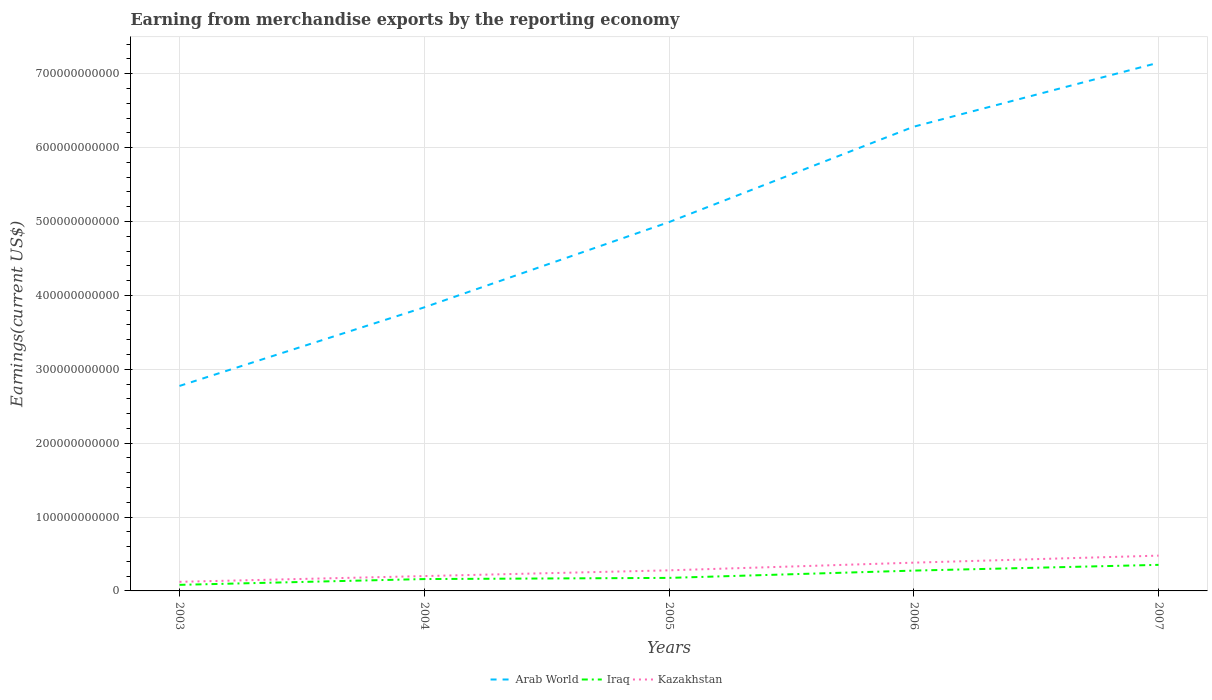How many different coloured lines are there?
Make the answer very short. 3. Across all years, what is the maximum amount earned from merchandise exports in Iraq?
Your answer should be compact. 8.22e+09. What is the total amount earned from merchandise exports in Iraq in the graph?
Offer a terse response. -1.14e+1. What is the difference between the highest and the second highest amount earned from merchandise exports in Iraq?
Offer a terse response. 2.71e+1. What is the difference between the highest and the lowest amount earned from merchandise exports in Iraq?
Provide a succinct answer. 2. Is the amount earned from merchandise exports in Iraq strictly greater than the amount earned from merchandise exports in Kazakhstan over the years?
Give a very brief answer. Yes. What is the difference between two consecutive major ticks on the Y-axis?
Ensure brevity in your answer.  1.00e+11. Are the values on the major ticks of Y-axis written in scientific E-notation?
Your answer should be compact. No. Does the graph contain any zero values?
Your answer should be compact. No. Does the graph contain grids?
Your answer should be very brief. Yes. Where does the legend appear in the graph?
Your answer should be very brief. Bottom center. What is the title of the graph?
Ensure brevity in your answer.  Earning from merchandise exports by the reporting economy. Does "Sub-Saharan Africa (developing only)" appear as one of the legend labels in the graph?
Keep it short and to the point. No. What is the label or title of the X-axis?
Provide a succinct answer. Years. What is the label or title of the Y-axis?
Your response must be concise. Earnings(current US$). What is the Earnings(current US$) in Arab World in 2003?
Your answer should be compact. 2.77e+11. What is the Earnings(current US$) of Iraq in 2003?
Your answer should be very brief. 8.22e+09. What is the Earnings(current US$) of Kazakhstan in 2003?
Keep it short and to the point. 1.23e+1. What is the Earnings(current US$) of Arab World in 2004?
Keep it short and to the point. 3.84e+11. What is the Earnings(current US$) of Iraq in 2004?
Your answer should be compact. 1.61e+1. What is the Earnings(current US$) of Kazakhstan in 2004?
Provide a short and direct response. 2.01e+1. What is the Earnings(current US$) of Arab World in 2005?
Your response must be concise. 4.99e+11. What is the Earnings(current US$) of Iraq in 2005?
Your response must be concise. 1.76e+1. What is the Earnings(current US$) in Kazakhstan in 2005?
Your answer should be compact. 2.79e+1. What is the Earnings(current US$) in Arab World in 2006?
Keep it short and to the point. 6.28e+11. What is the Earnings(current US$) in Iraq in 2006?
Provide a short and direct response. 2.75e+1. What is the Earnings(current US$) of Kazakhstan in 2006?
Your answer should be very brief. 3.83e+1. What is the Earnings(current US$) of Arab World in 2007?
Keep it short and to the point. 7.15e+11. What is the Earnings(current US$) in Iraq in 2007?
Your response must be concise. 3.53e+1. What is the Earnings(current US$) of Kazakhstan in 2007?
Keep it short and to the point. 4.78e+1. Across all years, what is the maximum Earnings(current US$) in Arab World?
Keep it short and to the point. 7.15e+11. Across all years, what is the maximum Earnings(current US$) of Iraq?
Your answer should be very brief. 3.53e+1. Across all years, what is the maximum Earnings(current US$) of Kazakhstan?
Offer a very short reply. 4.78e+1. Across all years, what is the minimum Earnings(current US$) of Arab World?
Your response must be concise. 2.77e+11. Across all years, what is the minimum Earnings(current US$) in Iraq?
Your answer should be compact. 8.22e+09. Across all years, what is the minimum Earnings(current US$) of Kazakhstan?
Offer a terse response. 1.23e+1. What is the total Earnings(current US$) of Arab World in the graph?
Make the answer very short. 2.50e+12. What is the total Earnings(current US$) in Iraq in the graph?
Keep it short and to the point. 1.05e+11. What is the total Earnings(current US$) in Kazakhstan in the graph?
Your answer should be compact. 1.46e+11. What is the difference between the Earnings(current US$) in Arab World in 2003 and that in 2004?
Ensure brevity in your answer.  -1.06e+11. What is the difference between the Earnings(current US$) in Iraq in 2003 and that in 2004?
Offer a very short reply. -7.84e+09. What is the difference between the Earnings(current US$) of Kazakhstan in 2003 and that in 2004?
Offer a very short reply. -7.79e+09. What is the difference between the Earnings(current US$) in Arab World in 2003 and that in 2005?
Keep it short and to the point. -2.22e+11. What is the difference between the Earnings(current US$) of Iraq in 2003 and that in 2005?
Offer a very short reply. -9.41e+09. What is the difference between the Earnings(current US$) in Kazakhstan in 2003 and that in 2005?
Keep it short and to the point. -1.55e+1. What is the difference between the Earnings(current US$) in Arab World in 2003 and that in 2006?
Offer a terse response. -3.51e+11. What is the difference between the Earnings(current US$) in Iraq in 2003 and that in 2006?
Offer a terse response. -1.93e+1. What is the difference between the Earnings(current US$) of Kazakhstan in 2003 and that in 2006?
Your response must be concise. -2.59e+1. What is the difference between the Earnings(current US$) of Arab World in 2003 and that in 2007?
Provide a succinct answer. -4.37e+11. What is the difference between the Earnings(current US$) in Iraq in 2003 and that in 2007?
Provide a short and direct response. -2.71e+1. What is the difference between the Earnings(current US$) in Kazakhstan in 2003 and that in 2007?
Offer a very short reply. -3.55e+1. What is the difference between the Earnings(current US$) of Arab World in 2004 and that in 2005?
Provide a short and direct response. -1.15e+11. What is the difference between the Earnings(current US$) in Iraq in 2004 and that in 2005?
Provide a short and direct response. -1.58e+09. What is the difference between the Earnings(current US$) of Kazakhstan in 2004 and that in 2005?
Make the answer very short. -7.76e+09. What is the difference between the Earnings(current US$) of Arab World in 2004 and that in 2006?
Offer a very short reply. -2.45e+11. What is the difference between the Earnings(current US$) in Iraq in 2004 and that in 2006?
Your answer should be very brief. -1.14e+1. What is the difference between the Earnings(current US$) of Kazakhstan in 2004 and that in 2006?
Your answer should be very brief. -1.82e+1. What is the difference between the Earnings(current US$) of Arab World in 2004 and that in 2007?
Provide a short and direct response. -3.31e+11. What is the difference between the Earnings(current US$) of Iraq in 2004 and that in 2007?
Make the answer very short. -1.92e+1. What is the difference between the Earnings(current US$) of Kazakhstan in 2004 and that in 2007?
Your answer should be very brief. -2.77e+1. What is the difference between the Earnings(current US$) of Arab World in 2005 and that in 2006?
Make the answer very short. -1.29e+11. What is the difference between the Earnings(current US$) of Iraq in 2005 and that in 2006?
Provide a succinct answer. -9.87e+09. What is the difference between the Earnings(current US$) in Kazakhstan in 2005 and that in 2006?
Your answer should be compact. -1.04e+1. What is the difference between the Earnings(current US$) of Arab World in 2005 and that in 2007?
Your response must be concise. -2.16e+11. What is the difference between the Earnings(current US$) of Iraq in 2005 and that in 2007?
Your response must be concise. -1.76e+1. What is the difference between the Earnings(current US$) of Kazakhstan in 2005 and that in 2007?
Offer a very short reply. -1.99e+1. What is the difference between the Earnings(current US$) of Arab World in 2006 and that in 2007?
Provide a succinct answer. -8.66e+1. What is the difference between the Earnings(current US$) of Iraq in 2006 and that in 2007?
Give a very brief answer. -7.77e+09. What is the difference between the Earnings(current US$) of Kazakhstan in 2006 and that in 2007?
Your answer should be compact. -9.51e+09. What is the difference between the Earnings(current US$) of Arab World in 2003 and the Earnings(current US$) of Iraq in 2004?
Your answer should be compact. 2.61e+11. What is the difference between the Earnings(current US$) in Arab World in 2003 and the Earnings(current US$) in Kazakhstan in 2004?
Make the answer very short. 2.57e+11. What is the difference between the Earnings(current US$) in Iraq in 2003 and the Earnings(current US$) in Kazakhstan in 2004?
Offer a terse response. -1.19e+1. What is the difference between the Earnings(current US$) in Arab World in 2003 and the Earnings(current US$) in Iraq in 2005?
Your answer should be very brief. 2.60e+11. What is the difference between the Earnings(current US$) in Arab World in 2003 and the Earnings(current US$) in Kazakhstan in 2005?
Provide a short and direct response. 2.50e+11. What is the difference between the Earnings(current US$) in Iraq in 2003 and the Earnings(current US$) in Kazakhstan in 2005?
Your response must be concise. -1.96e+1. What is the difference between the Earnings(current US$) in Arab World in 2003 and the Earnings(current US$) in Iraq in 2006?
Keep it short and to the point. 2.50e+11. What is the difference between the Earnings(current US$) in Arab World in 2003 and the Earnings(current US$) in Kazakhstan in 2006?
Make the answer very short. 2.39e+11. What is the difference between the Earnings(current US$) of Iraq in 2003 and the Earnings(current US$) of Kazakhstan in 2006?
Your response must be concise. -3.00e+1. What is the difference between the Earnings(current US$) in Arab World in 2003 and the Earnings(current US$) in Iraq in 2007?
Provide a succinct answer. 2.42e+11. What is the difference between the Earnings(current US$) in Arab World in 2003 and the Earnings(current US$) in Kazakhstan in 2007?
Your answer should be very brief. 2.30e+11. What is the difference between the Earnings(current US$) in Iraq in 2003 and the Earnings(current US$) in Kazakhstan in 2007?
Keep it short and to the point. -3.95e+1. What is the difference between the Earnings(current US$) of Arab World in 2004 and the Earnings(current US$) of Iraq in 2005?
Your answer should be compact. 3.66e+11. What is the difference between the Earnings(current US$) in Arab World in 2004 and the Earnings(current US$) in Kazakhstan in 2005?
Offer a very short reply. 3.56e+11. What is the difference between the Earnings(current US$) of Iraq in 2004 and the Earnings(current US$) of Kazakhstan in 2005?
Offer a terse response. -1.18e+1. What is the difference between the Earnings(current US$) in Arab World in 2004 and the Earnings(current US$) in Iraq in 2006?
Keep it short and to the point. 3.56e+11. What is the difference between the Earnings(current US$) of Arab World in 2004 and the Earnings(current US$) of Kazakhstan in 2006?
Make the answer very short. 3.46e+11. What is the difference between the Earnings(current US$) in Iraq in 2004 and the Earnings(current US$) in Kazakhstan in 2006?
Offer a very short reply. -2.22e+1. What is the difference between the Earnings(current US$) of Arab World in 2004 and the Earnings(current US$) of Iraq in 2007?
Ensure brevity in your answer.  3.48e+11. What is the difference between the Earnings(current US$) of Arab World in 2004 and the Earnings(current US$) of Kazakhstan in 2007?
Provide a short and direct response. 3.36e+11. What is the difference between the Earnings(current US$) of Iraq in 2004 and the Earnings(current US$) of Kazakhstan in 2007?
Keep it short and to the point. -3.17e+1. What is the difference between the Earnings(current US$) in Arab World in 2005 and the Earnings(current US$) in Iraq in 2006?
Offer a very short reply. 4.72e+11. What is the difference between the Earnings(current US$) in Arab World in 2005 and the Earnings(current US$) in Kazakhstan in 2006?
Offer a very short reply. 4.61e+11. What is the difference between the Earnings(current US$) of Iraq in 2005 and the Earnings(current US$) of Kazakhstan in 2006?
Keep it short and to the point. -2.06e+1. What is the difference between the Earnings(current US$) in Arab World in 2005 and the Earnings(current US$) in Iraq in 2007?
Provide a succinct answer. 4.64e+11. What is the difference between the Earnings(current US$) of Arab World in 2005 and the Earnings(current US$) of Kazakhstan in 2007?
Your response must be concise. 4.51e+11. What is the difference between the Earnings(current US$) in Iraq in 2005 and the Earnings(current US$) in Kazakhstan in 2007?
Offer a very short reply. -3.01e+1. What is the difference between the Earnings(current US$) in Arab World in 2006 and the Earnings(current US$) in Iraq in 2007?
Offer a very short reply. 5.93e+11. What is the difference between the Earnings(current US$) of Arab World in 2006 and the Earnings(current US$) of Kazakhstan in 2007?
Offer a very short reply. 5.81e+11. What is the difference between the Earnings(current US$) in Iraq in 2006 and the Earnings(current US$) in Kazakhstan in 2007?
Keep it short and to the point. -2.03e+1. What is the average Earnings(current US$) of Arab World per year?
Keep it short and to the point. 5.01e+11. What is the average Earnings(current US$) in Iraq per year?
Provide a succinct answer. 2.09e+1. What is the average Earnings(current US$) of Kazakhstan per year?
Your answer should be very brief. 2.93e+1. In the year 2003, what is the difference between the Earnings(current US$) in Arab World and Earnings(current US$) in Iraq?
Ensure brevity in your answer.  2.69e+11. In the year 2003, what is the difference between the Earnings(current US$) in Arab World and Earnings(current US$) in Kazakhstan?
Offer a terse response. 2.65e+11. In the year 2003, what is the difference between the Earnings(current US$) in Iraq and Earnings(current US$) in Kazakhstan?
Your answer should be very brief. -4.09e+09. In the year 2004, what is the difference between the Earnings(current US$) in Arab World and Earnings(current US$) in Iraq?
Offer a very short reply. 3.68e+11. In the year 2004, what is the difference between the Earnings(current US$) of Arab World and Earnings(current US$) of Kazakhstan?
Your response must be concise. 3.64e+11. In the year 2004, what is the difference between the Earnings(current US$) of Iraq and Earnings(current US$) of Kazakhstan?
Offer a very short reply. -4.04e+09. In the year 2005, what is the difference between the Earnings(current US$) of Arab World and Earnings(current US$) of Iraq?
Your answer should be very brief. 4.82e+11. In the year 2005, what is the difference between the Earnings(current US$) in Arab World and Earnings(current US$) in Kazakhstan?
Offer a very short reply. 4.71e+11. In the year 2005, what is the difference between the Earnings(current US$) in Iraq and Earnings(current US$) in Kazakhstan?
Ensure brevity in your answer.  -1.02e+1. In the year 2006, what is the difference between the Earnings(current US$) in Arab World and Earnings(current US$) in Iraq?
Offer a very short reply. 6.01e+11. In the year 2006, what is the difference between the Earnings(current US$) of Arab World and Earnings(current US$) of Kazakhstan?
Provide a succinct answer. 5.90e+11. In the year 2006, what is the difference between the Earnings(current US$) of Iraq and Earnings(current US$) of Kazakhstan?
Make the answer very short. -1.08e+1. In the year 2007, what is the difference between the Earnings(current US$) in Arab World and Earnings(current US$) in Iraq?
Keep it short and to the point. 6.80e+11. In the year 2007, what is the difference between the Earnings(current US$) of Arab World and Earnings(current US$) of Kazakhstan?
Provide a short and direct response. 6.67e+11. In the year 2007, what is the difference between the Earnings(current US$) in Iraq and Earnings(current US$) in Kazakhstan?
Your answer should be compact. -1.25e+1. What is the ratio of the Earnings(current US$) of Arab World in 2003 to that in 2004?
Offer a very short reply. 0.72. What is the ratio of the Earnings(current US$) in Iraq in 2003 to that in 2004?
Make the answer very short. 0.51. What is the ratio of the Earnings(current US$) of Kazakhstan in 2003 to that in 2004?
Provide a short and direct response. 0.61. What is the ratio of the Earnings(current US$) in Arab World in 2003 to that in 2005?
Offer a very short reply. 0.56. What is the ratio of the Earnings(current US$) of Iraq in 2003 to that in 2005?
Offer a terse response. 0.47. What is the ratio of the Earnings(current US$) of Kazakhstan in 2003 to that in 2005?
Provide a succinct answer. 0.44. What is the ratio of the Earnings(current US$) of Arab World in 2003 to that in 2006?
Provide a succinct answer. 0.44. What is the ratio of the Earnings(current US$) in Iraq in 2003 to that in 2006?
Ensure brevity in your answer.  0.3. What is the ratio of the Earnings(current US$) of Kazakhstan in 2003 to that in 2006?
Offer a very short reply. 0.32. What is the ratio of the Earnings(current US$) in Arab World in 2003 to that in 2007?
Ensure brevity in your answer.  0.39. What is the ratio of the Earnings(current US$) of Iraq in 2003 to that in 2007?
Give a very brief answer. 0.23. What is the ratio of the Earnings(current US$) of Kazakhstan in 2003 to that in 2007?
Keep it short and to the point. 0.26. What is the ratio of the Earnings(current US$) of Arab World in 2004 to that in 2005?
Give a very brief answer. 0.77. What is the ratio of the Earnings(current US$) in Iraq in 2004 to that in 2005?
Make the answer very short. 0.91. What is the ratio of the Earnings(current US$) in Kazakhstan in 2004 to that in 2005?
Your answer should be compact. 0.72. What is the ratio of the Earnings(current US$) in Arab World in 2004 to that in 2006?
Your response must be concise. 0.61. What is the ratio of the Earnings(current US$) in Iraq in 2004 to that in 2006?
Provide a succinct answer. 0.58. What is the ratio of the Earnings(current US$) of Kazakhstan in 2004 to that in 2006?
Your response must be concise. 0.53. What is the ratio of the Earnings(current US$) of Arab World in 2004 to that in 2007?
Ensure brevity in your answer.  0.54. What is the ratio of the Earnings(current US$) of Iraq in 2004 to that in 2007?
Ensure brevity in your answer.  0.46. What is the ratio of the Earnings(current US$) in Kazakhstan in 2004 to that in 2007?
Provide a short and direct response. 0.42. What is the ratio of the Earnings(current US$) of Arab World in 2005 to that in 2006?
Your answer should be compact. 0.79. What is the ratio of the Earnings(current US$) of Iraq in 2005 to that in 2006?
Make the answer very short. 0.64. What is the ratio of the Earnings(current US$) of Kazakhstan in 2005 to that in 2006?
Provide a short and direct response. 0.73. What is the ratio of the Earnings(current US$) in Arab World in 2005 to that in 2007?
Give a very brief answer. 0.7. What is the ratio of the Earnings(current US$) in Iraq in 2005 to that in 2007?
Provide a short and direct response. 0.5. What is the ratio of the Earnings(current US$) of Kazakhstan in 2005 to that in 2007?
Provide a short and direct response. 0.58. What is the ratio of the Earnings(current US$) in Arab World in 2006 to that in 2007?
Your answer should be very brief. 0.88. What is the ratio of the Earnings(current US$) of Iraq in 2006 to that in 2007?
Provide a succinct answer. 0.78. What is the ratio of the Earnings(current US$) of Kazakhstan in 2006 to that in 2007?
Give a very brief answer. 0.8. What is the difference between the highest and the second highest Earnings(current US$) of Arab World?
Give a very brief answer. 8.66e+1. What is the difference between the highest and the second highest Earnings(current US$) in Iraq?
Provide a short and direct response. 7.77e+09. What is the difference between the highest and the second highest Earnings(current US$) of Kazakhstan?
Your answer should be very brief. 9.51e+09. What is the difference between the highest and the lowest Earnings(current US$) in Arab World?
Your response must be concise. 4.37e+11. What is the difference between the highest and the lowest Earnings(current US$) in Iraq?
Provide a succinct answer. 2.71e+1. What is the difference between the highest and the lowest Earnings(current US$) in Kazakhstan?
Provide a succinct answer. 3.55e+1. 